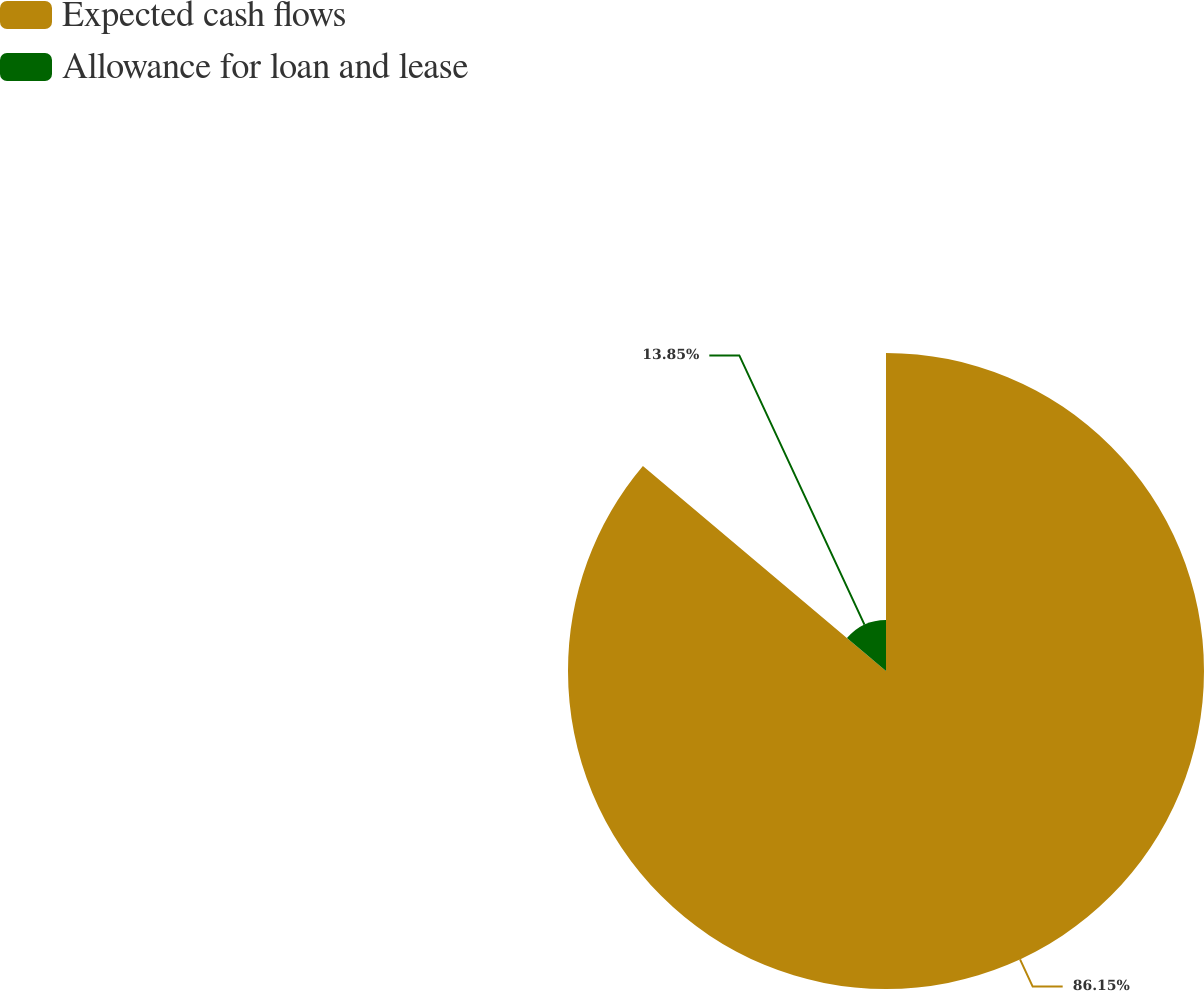Convert chart. <chart><loc_0><loc_0><loc_500><loc_500><pie_chart><fcel>Expected cash flows<fcel>Allowance for loan and lease<nl><fcel>86.15%<fcel>13.85%<nl></chart> 